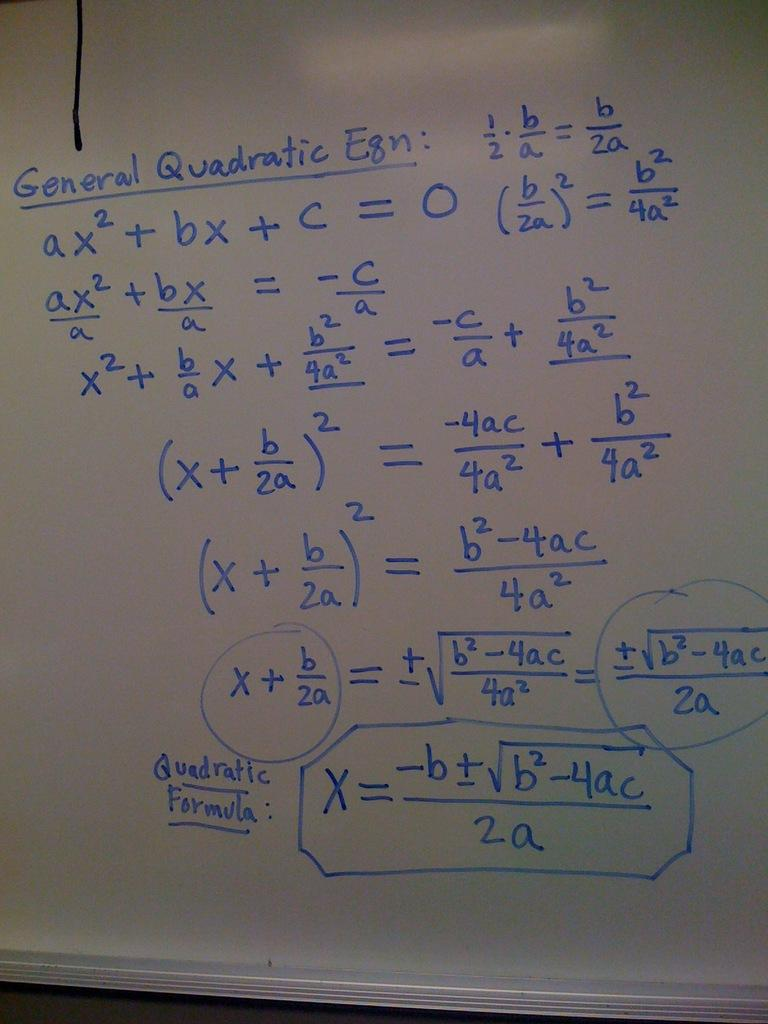<image>
Relay a brief, clear account of the picture shown. the word general that is on the white board 